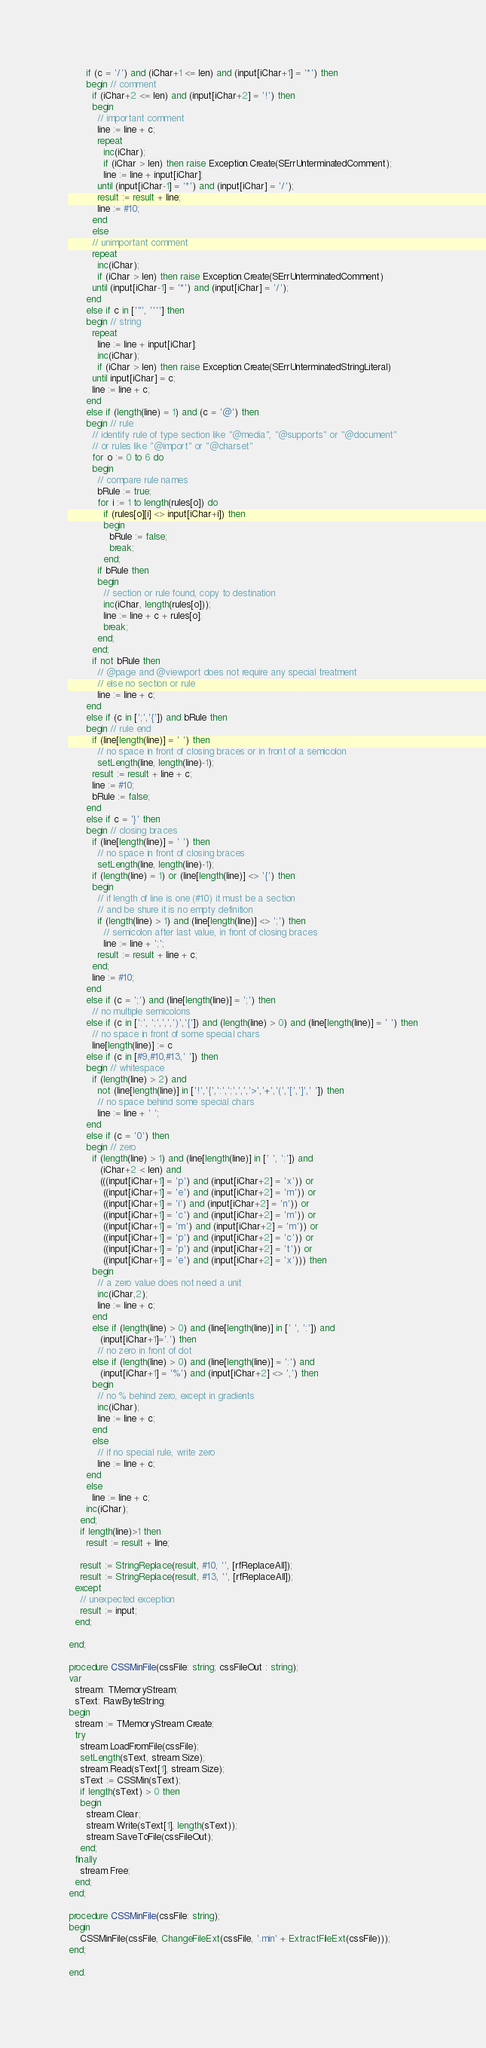Convert code to text. <code><loc_0><loc_0><loc_500><loc_500><_Pascal_>      if (c = '/') and (iChar+1 <= len) and (input[iChar+1] = '*') then
      begin // comment
        if (iChar+2 <= len) and (input[iChar+2] = '!') then
        begin
          // important comment
          line := line + c;
          repeat
            inc(iChar);
            if (iChar > len) then raise Exception.Create(SErrUnterminatedComment);
            line := line + input[iChar];
          until (input[iChar-1] = '*') and (input[iChar] = '/');
          result := result + line;
          line := #10;
        end
        else
        // unimportant comment
        repeat
          inc(iChar);
          if (iChar > len) then raise Exception.Create(SErrUnterminatedComment)
        until (input[iChar-1] = '*') and (input[iChar] = '/');
      end
      else if c in ['"', ''''] then
      begin // string
        repeat
          line := line + input[iChar];
          inc(iChar);
          if (iChar > len) then raise Exception.Create(SErrUnterminatedStringLiteral)
        until input[iChar] = c;
        line := line + c;
      end
      else if (length(line) = 1) and (c = '@') then
      begin // rule
        // identify rule of type section like "@media", "@supports" or "@document"
        // or rules like "@import" or "@charset"
        for o := 0 to 6 do
        begin
          // compare rule names
          bRule := true;
          for i := 1 to length(rules[o]) do
            if (rules[o][i] <> input[iChar+i]) then
            begin
              bRule := false;
              break;
            end;
          if bRule then
          begin
            // section or rule found, copy to destination
            inc(iChar, length(rules[o]));
            line := line + c + rules[o];
            break;
          end;
        end;
        if not bRule then
          // @page and @viewport does not require any special treatment
          // else no section or rule
          line := line + c;
      end
      else if (c in [';','{']) and bRule then
      begin // rule end
        if (line[length(line)] = ' ') then
          // no space in front of closing braces or in front of a semicolon
          setLength(line, length(line)-1);
        result := result + line + c;
        line := #10;
        bRule := false;
      end
      else if c = '}' then
      begin // closing braces
        if (line[length(line)] = ' ') then
          // no space in front of closing braces
          setLength(line, length(line)-1);
        if (length(line) = 1) or (line[length(line)] <> '{') then
        begin
          // if length of line is one (#10) it must be a section
          // and be shure it is no empty definition
          if (length(line) > 1) and (line[length(line)] <> ';') then
            // semicolon after last value, in front of closing braces
            line := line + ';';
          result := result + line + c;
        end;
        line := #10;
      end
      else if (c = ';') and (line[length(line)] = ';') then
        // no multiple semicolons
      else if (c in [':', ';',',',')','{']) and (length(line) > 0) and (line[length(line)] = ' ') then
        // no space in front of some special chars
        line[length(line)] := c
      else if (c in [#9,#10,#13,' ']) then
      begin // whitespace
        if (length(line) > 2) and
          not (line[length(line)] in ['!','{',':',';',',','>','+','(','[',']',' ']) then
          // no space behind some special chars
          line := line + ' ';
      end
      else if (c = '0') then
      begin // zero
        if (length(line) > 1) and (line[length(line)] in [' ', ':']) and
           (iChar+2 < len) and
           (((input[iChar+1] = 'p') and (input[iChar+2] = 'x')) or
            ((input[iChar+1] = 'e') and (input[iChar+2] = 'm')) or
            ((input[iChar+1] = 'i') and (input[iChar+2] = 'n')) or
            ((input[iChar+1] = 'c') and (input[iChar+2] = 'm')) or
            ((input[iChar+1] = 'm') and (input[iChar+2] = 'm')) or
            ((input[iChar+1] = 'p') and (input[iChar+2] = 'c')) or
            ((input[iChar+1] = 'p') and (input[iChar+2] = 't')) or
            ((input[iChar+1] = 'e') and (input[iChar+2] = 'x'))) then
        begin
          // a zero value does not need a unit
          inc(iChar,2);
          line := line + c;
        end
        else if (length(line) > 0) and (line[length(line)] in [' ', ':']) and
           (input[iChar+1]='.') then
          // no zero in front of dot
        else if (length(line) > 0) and (line[length(line)] = ':') and
           (input[iChar+1] = '%') and (input[iChar+2] <> ',') then
        begin
          // no % behind zero, except in gradients
          inc(iChar);
          line := line + c;
        end
        else
          // if no special rule, write zero
          line := line + c;
      end
      else
        line := line + c;
      inc(iChar);
    end;
    if length(line)>1 then
      result := result + line;

    result := StringReplace(result, #10, '', [rfReplaceAll]);
    result := StringReplace(result, #13, '', [rfReplaceAll]);
  except
    // unexpected exception
    result := input;
  end;

end;

procedure CSSMinFile(cssFile: string; cssFileOut : string);
var
  stream: TMemoryStream;
  sText: RawByteString;
begin
  stream := TMemoryStream.Create;
  try
    stream.LoadFromFile(cssFile);
    setLength(sText, stream.Size);
    stream.Read(sText[1], stream.Size);
    sText := CSSMin(sText);
    if length(sText) > 0 then
    begin
      stream.Clear;
      stream.Write(sText[1], length(sText));
      stream.SaveToFile(cssFileOut);
    end;
  finally
    stream.Free;
  end;
end;

procedure CSSMinFile(cssFile: string);
begin
    CSSMinFile(cssFile, ChangeFileExt(cssFile, '.min' + ExtractFileExt(cssFile)));
end;

end.
</code> 